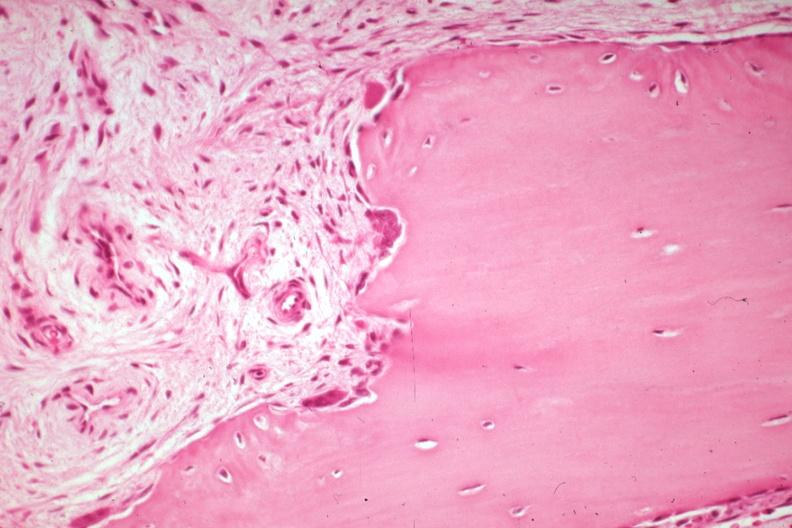what does this image show?
Answer the question using a single word or phrase. High excellent bone remodeling with osteoclasts and osteoblasts 81 